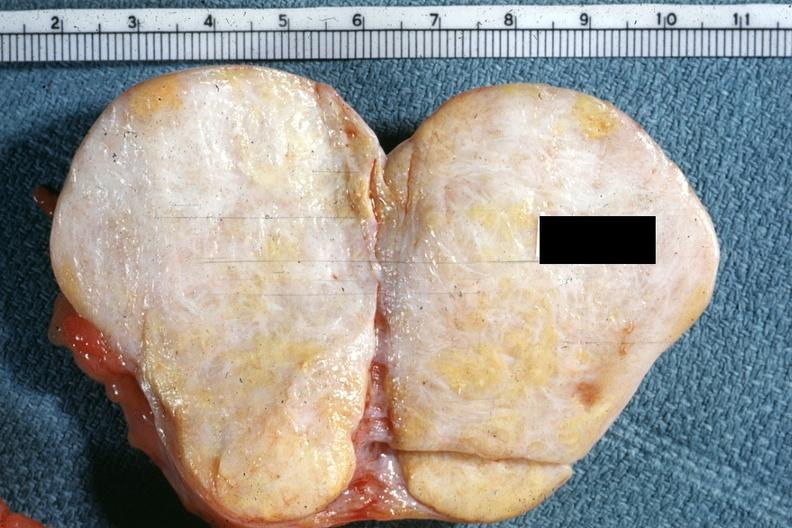s thecoma present?
Answer the question using a single word or phrase. Yes 